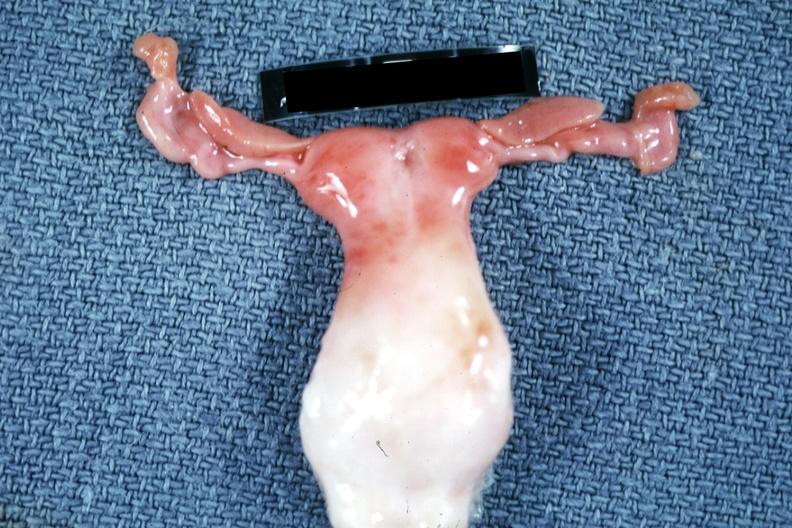does this show infant bicornate uterus?
Answer the question using a single word or phrase. No 